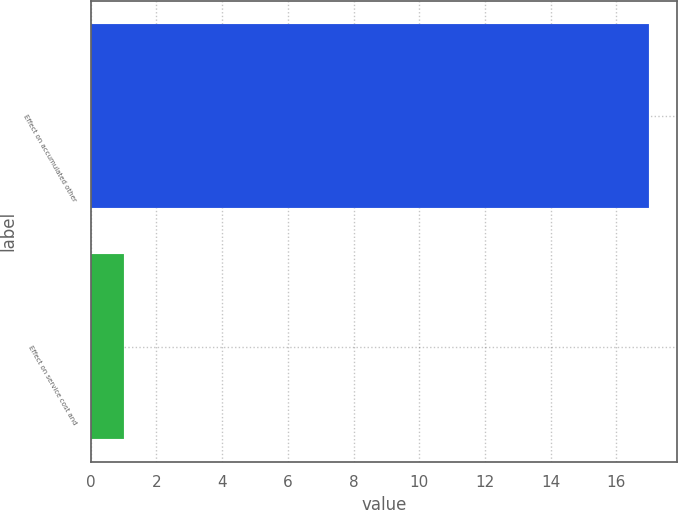Convert chart. <chart><loc_0><loc_0><loc_500><loc_500><bar_chart><fcel>Effect on accumulated other<fcel>Effect on service cost and<nl><fcel>17<fcel>1<nl></chart> 